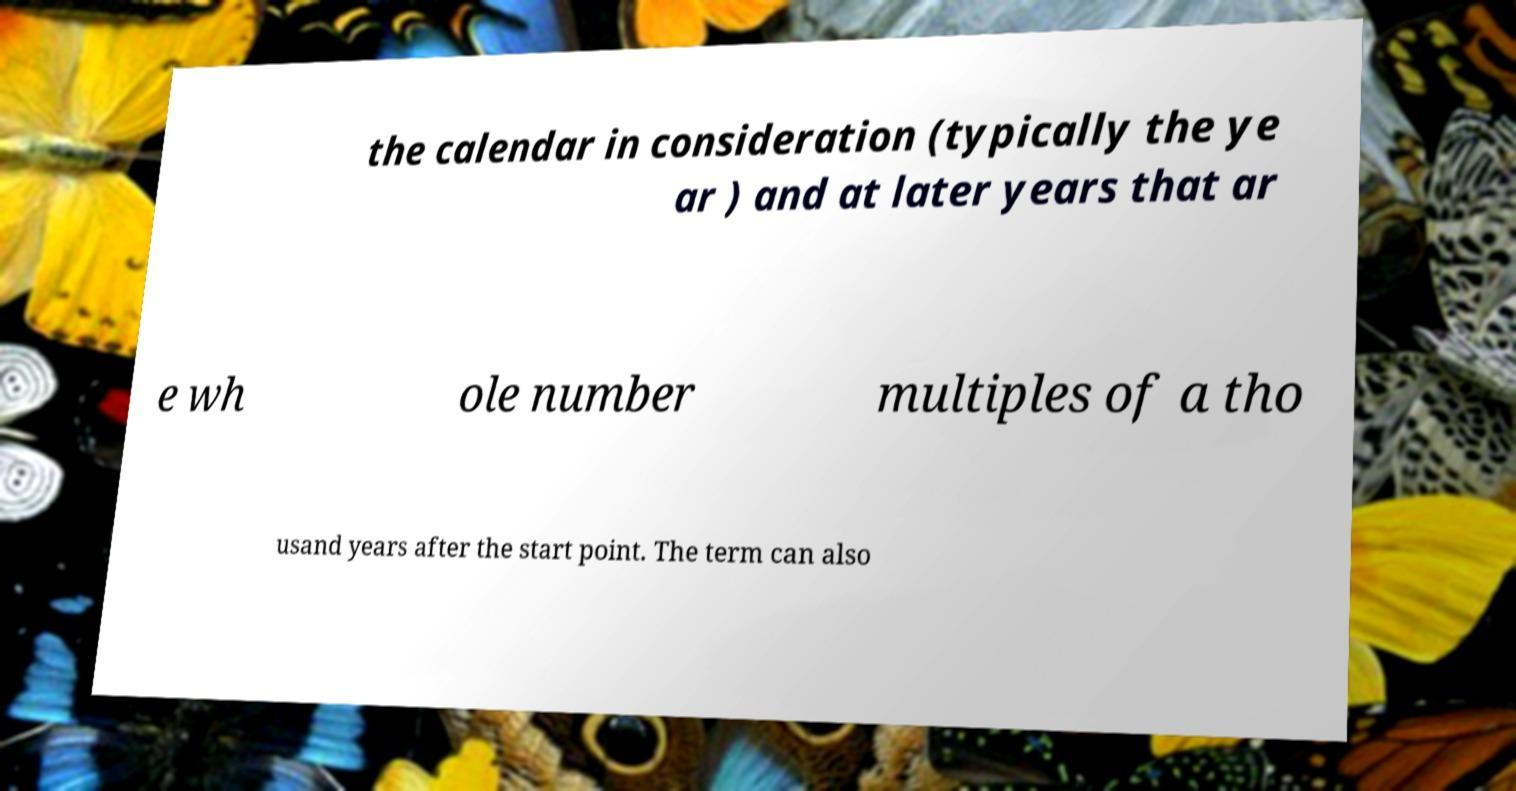Can you accurately transcribe the text from the provided image for me? the calendar in consideration (typically the ye ar ) and at later years that ar e wh ole number multiples of a tho usand years after the start point. The term can also 